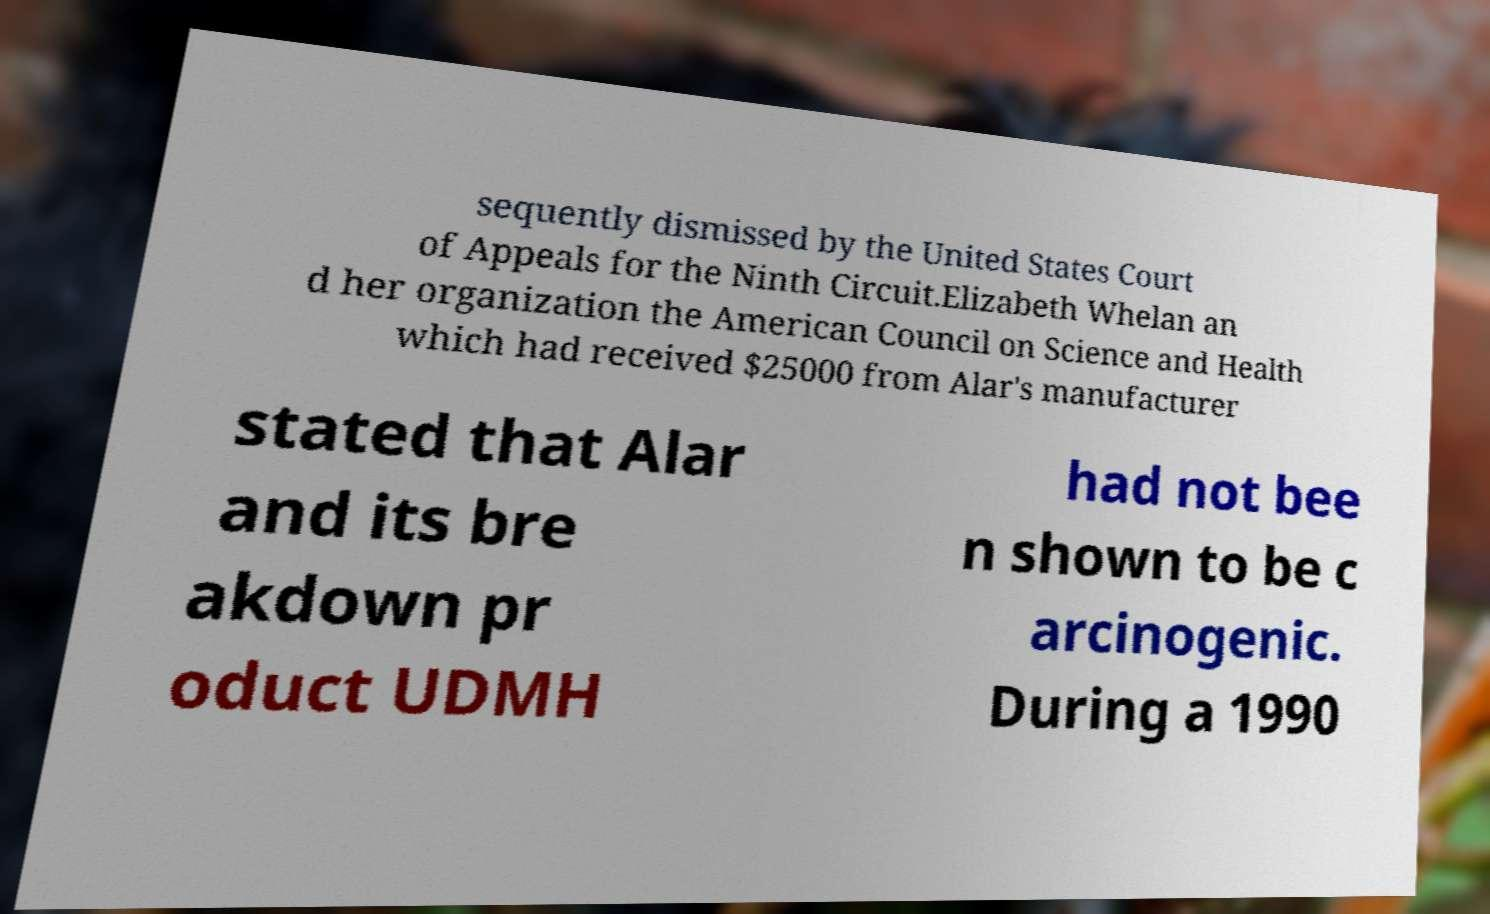Can you accurately transcribe the text from the provided image for me? sequently dismissed by the United States Court of Appeals for the Ninth Circuit.Elizabeth Whelan an d her organization the American Council on Science and Health which had received $25000 from Alar's manufacturer stated that Alar and its bre akdown pr oduct UDMH had not bee n shown to be c arcinogenic. During a 1990 